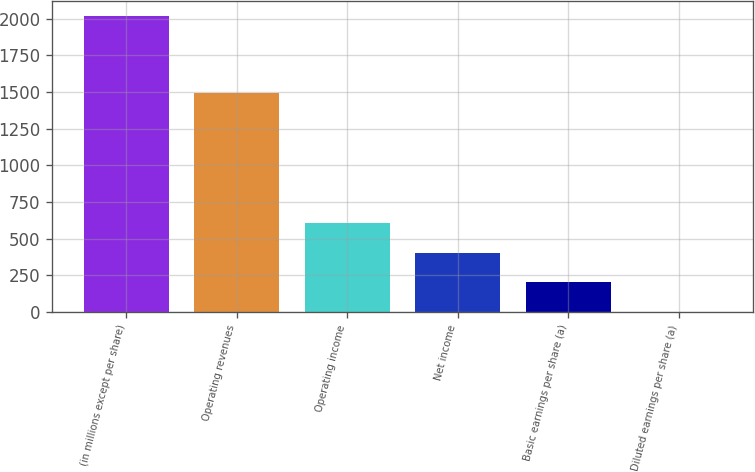<chart> <loc_0><loc_0><loc_500><loc_500><bar_chart><fcel>(in millions except per share)<fcel>Operating revenues<fcel>Operating income<fcel>Net income<fcel>Basic earnings per share (a)<fcel>Diluted earnings per share (a)<nl><fcel>2016<fcel>1494<fcel>606.27<fcel>404.88<fcel>203.49<fcel>2.1<nl></chart> 